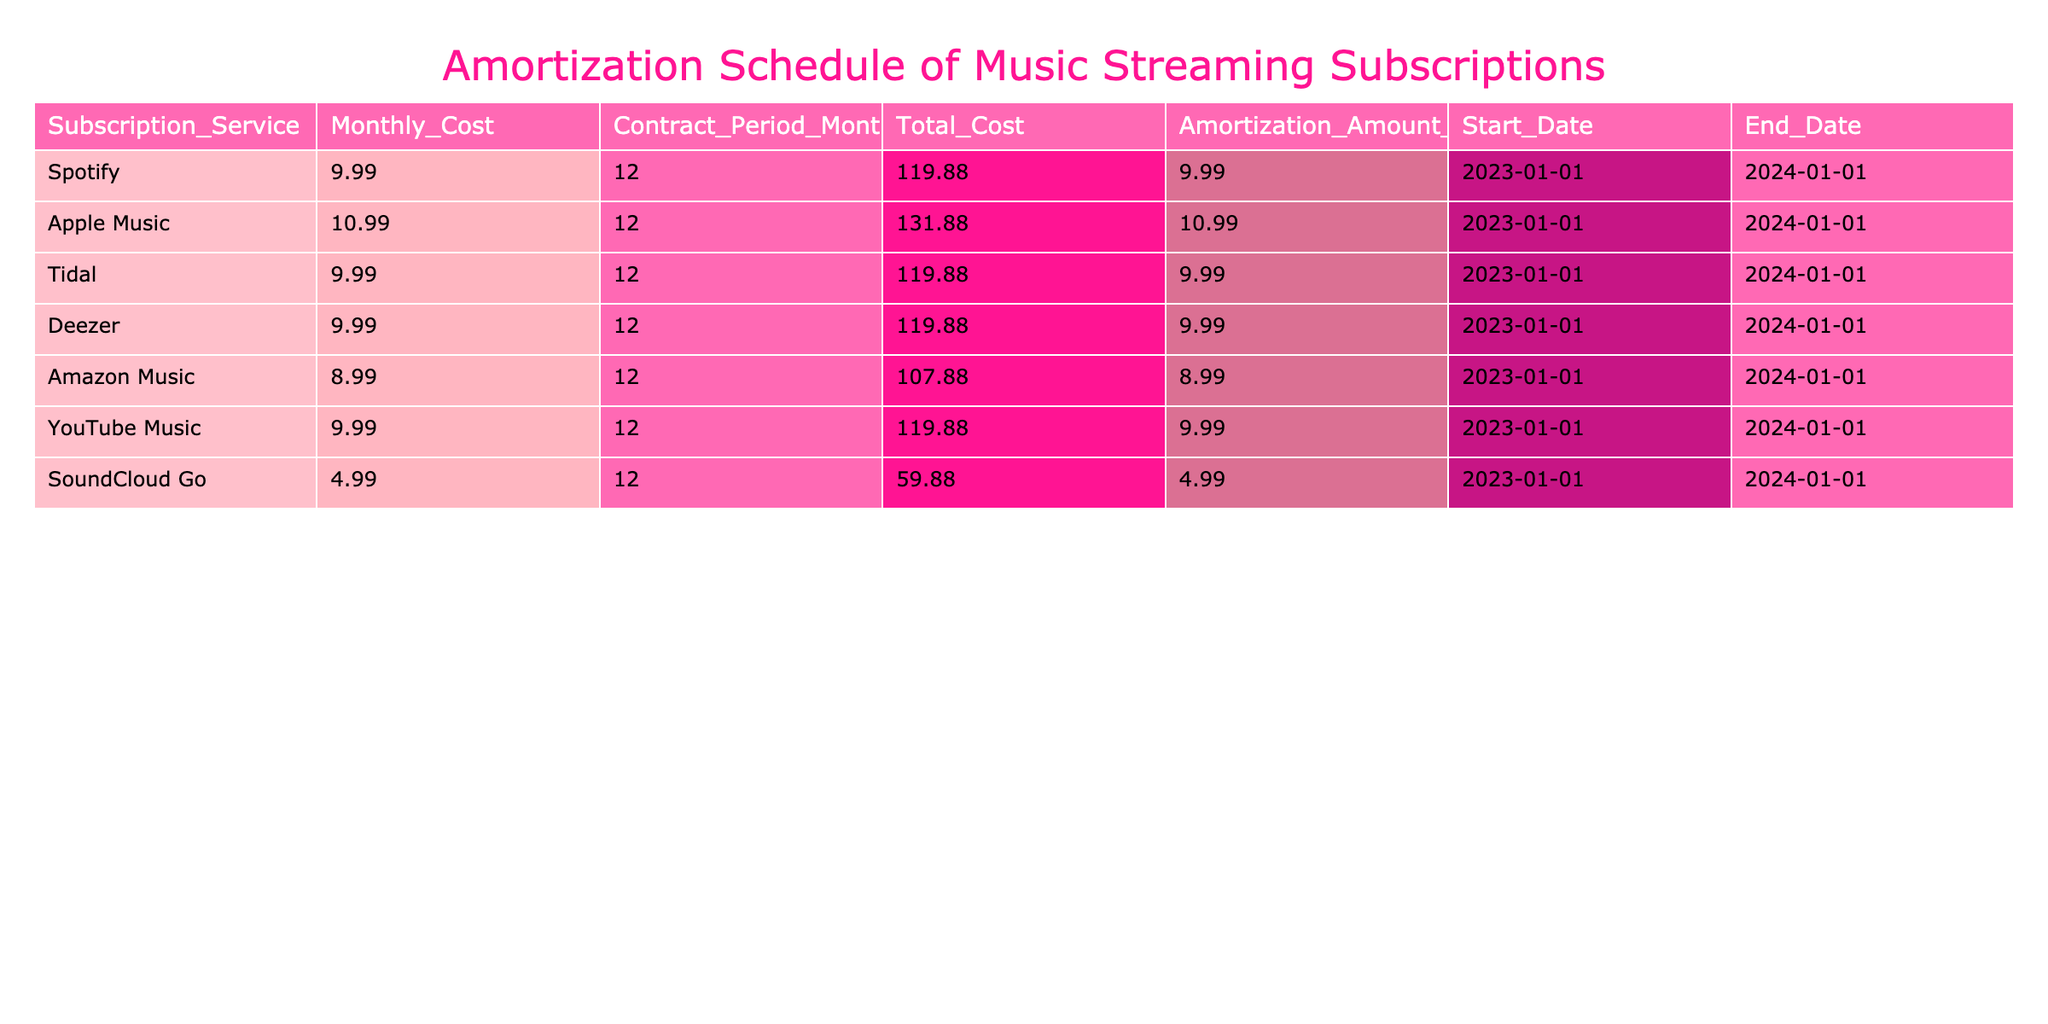What is the monthly cost of the Amazon Music subscription? The table lists the "Monthly_Cost" for Amazon Music, which is directly provided in the same row. The value for Amazon Music is 8.99.
Answer: 8.99 What is the total cost of the Deezer subscription over the contract period? The "Total_Cost" column for Deezer shows the value of 119.88, which reflects the total amount spent during the 12-month contract.
Answer: 119.88 Is the monthly cost of Apple Music higher than that of Spotify? By comparing the values in the "Monthly_Cost" column for both services, Apple Music is 10.99 and Spotify is 9.99. Since 10.99 is greater than 9.99, the answer is yes.
Answer: Yes What is the average monthly cost across all subscription services listed? To find the average, sum all the monthly costs: (9.99 + 10.99 + 9.99 + 9.99 + 8.99 + 9.99 + 4.99) = 64.93. Then divide by the number of services (7), which gives 64.93/7 = 9.21.
Answer: 9.21 Which subscription service has the lowest total cost? From the "Total_Cost" column, look for the minimum value. The lowest value is 59.88 for SoundCloud Go.
Answer: SoundCloud Go How many subscription services have a monthly cost greater than 9? Count the services in the "Monthly_Cost" column that are above 9.99: Apple Music (10.99), and Deezer (9.99). This makes 5 in total: Apple Music, Spotify, Tidal, YouTube Music, and Deezer.
Answer: 5 What is the total cost for all subscription services combined? Add all the values in the "Total_Cost" column: (119.88 + 131.88 + 119.88 + 119.88 + 107.88 + 119.88 + 59.88) = 888.28.
Answer: 888.28 Does Tidal have the same monthly cost as SoundCloud Go? Compare the monthly costs: Tidal is 9.99 and SoundCloud Go is 4.99. Since they are different, the answer is no.
Answer: No 